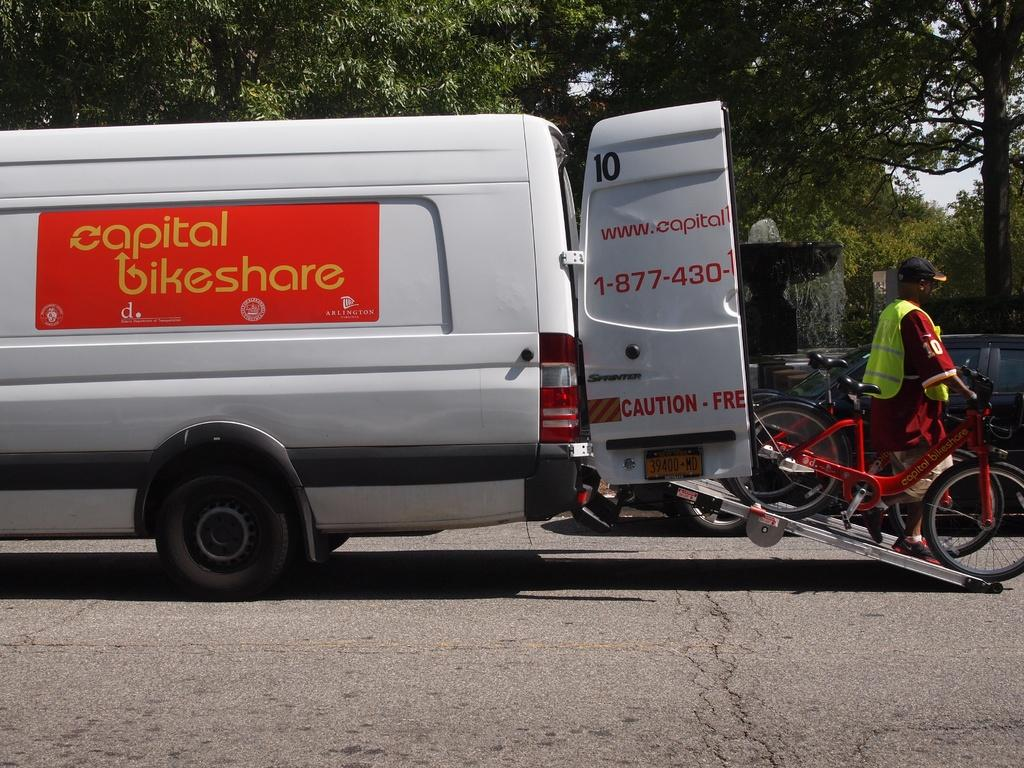What can be seen on the road in the image? There are vehicles on the road in the image. What is the person in the image doing with the bicycle? The person is holding a bicycle in the image. What is located in the background of the image? There is a water fountain, trees, and the sky visible in the background of the image. How many chairs are visible in the image? There are no chairs present in the image. Is the water fountain located at an airport in the image? The image does not show any airport, and the water fountain is not specifically mentioned as being at an airport. 